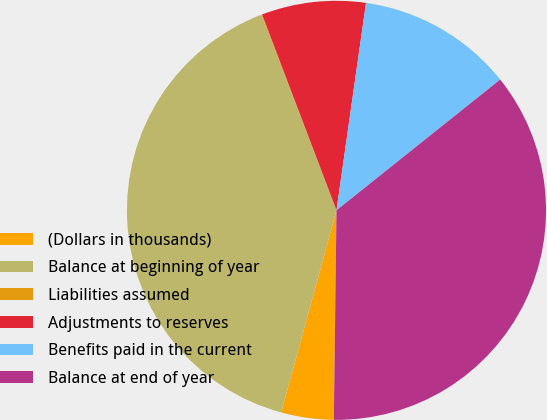Convert chart to OTSL. <chart><loc_0><loc_0><loc_500><loc_500><pie_chart><fcel>(Dollars in thousands)<fcel>Balance at beginning of year<fcel>Liabilities assumed<fcel>Adjustments to reserves<fcel>Benefits paid in the current<fcel>Balance at end of year<nl><fcel>4.05%<fcel>39.91%<fcel>0.06%<fcel>8.03%<fcel>12.02%<fcel>35.93%<nl></chart> 